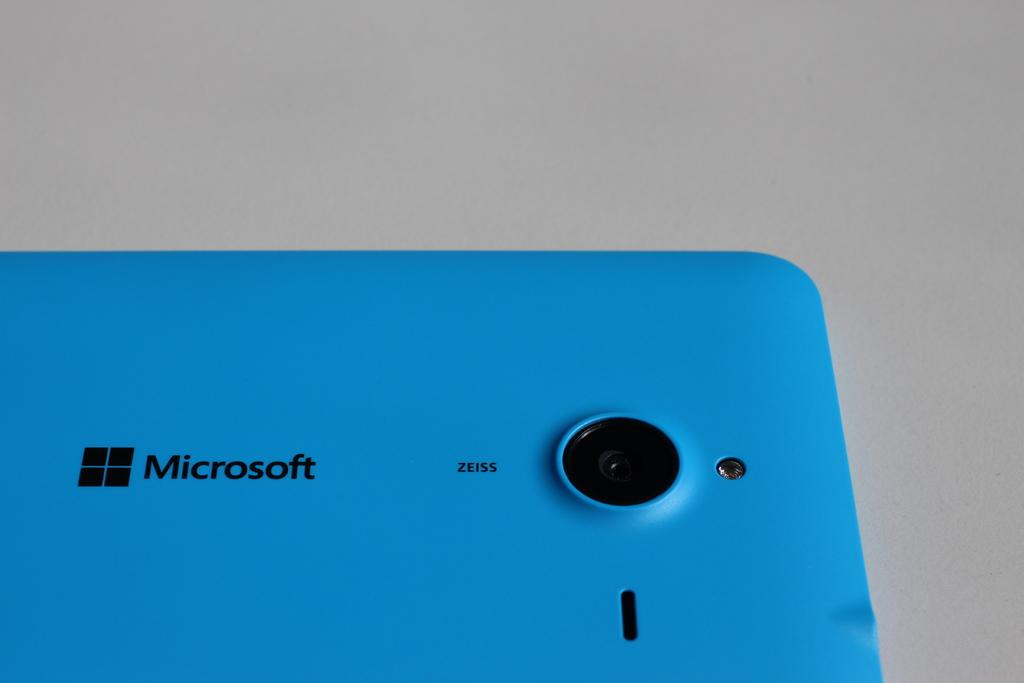<image>
Render a clear and concise summary of the photo. A blue Microsoft device laying on its face. 